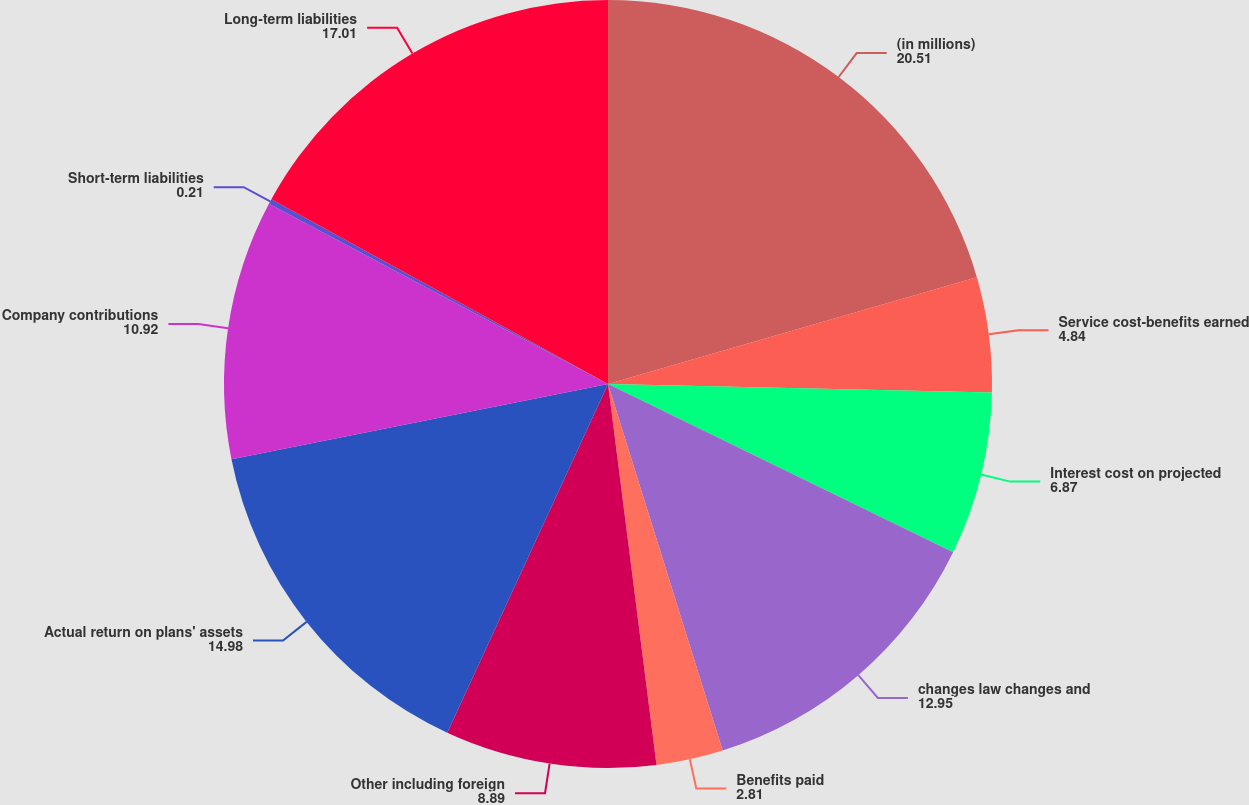Convert chart. <chart><loc_0><loc_0><loc_500><loc_500><pie_chart><fcel>(in millions)<fcel>Service cost-benefits earned<fcel>Interest cost on projected<fcel>changes law changes and<fcel>Benefits paid<fcel>Other including foreign<fcel>Actual return on plans' assets<fcel>Company contributions<fcel>Short-term liabilities<fcel>Long-term liabilities<nl><fcel>20.51%<fcel>4.84%<fcel>6.87%<fcel>12.95%<fcel>2.81%<fcel>8.89%<fcel>14.98%<fcel>10.92%<fcel>0.21%<fcel>17.01%<nl></chart> 